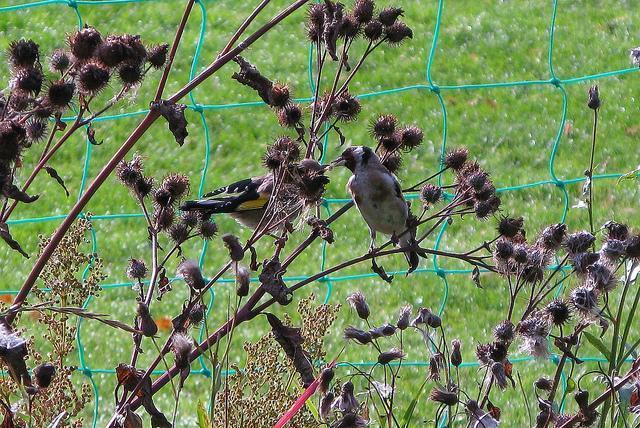How many birds are there?
Give a very brief answer. 2. How many birds can you see?
Give a very brief answer. 2. How many blue cars are there?
Give a very brief answer. 0. 